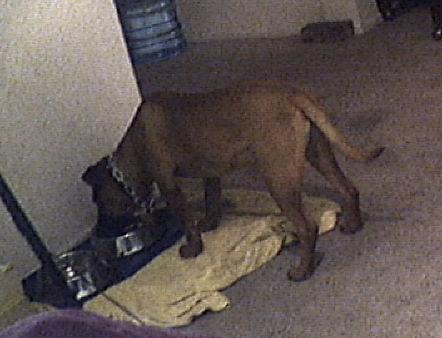How many dogs can be seen?
Give a very brief answer. 1. How many watches does the woman have on?
Give a very brief answer. 0. 